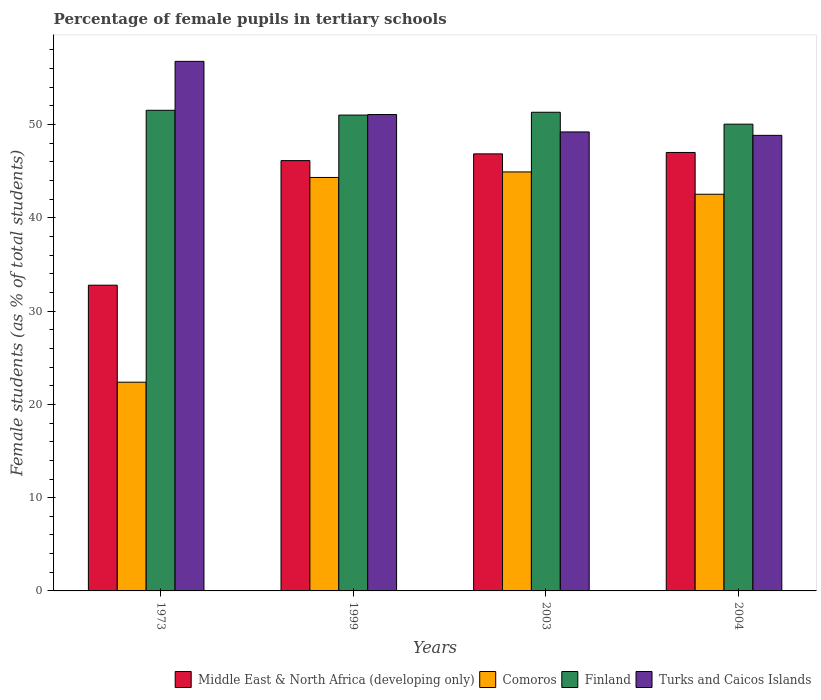How many different coloured bars are there?
Offer a terse response. 4. Are the number of bars on each tick of the X-axis equal?
Your answer should be very brief. Yes. How many bars are there on the 1st tick from the right?
Provide a succinct answer. 4. What is the percentage of female pupils in tertiary schools in Comoros in 1973?
Keep it short and to the point. 22.38. Across all years, what is the maximum percentage of female pupils in tertiary schools in Finland?
Your answer should be compact. 51.53. Across all years, what is the minimum percentage of female pupils in tertiary schools in Turks and Caicos Islands?
Keep it short and to the point. 48.85. In which year was the percentage of female pupils in tertiary schools in Finland maximum?
Ensure brevity in your answer.  1973. In which year was the percentage of female pupils in tertiary schools in Comoros minimum?
Ensure brevity in your answer.  1973. What is the total percentage of female pupils in tertiary schools in Comoros in the graph?
Keep it short and to the point. 154.16. What is the difference between the percentage of female pupils in tertiary schools in Middle East & North Africa (developing only) in 1973 and that in 2003?
Make the answer very short. -14.08. What is the difference between the percentage of female pupils in tertiary schools in Finland in 2003 and the percentage of female pupils in tertiary schools in Turks and Caicos Islands in 1999?
Ensure brevity in your answer.  0.24. What is the average percentage of female pupils in tertiary schools in Turks and Caicos Islands per year?
Offer a very short reply. 51.48. In the year 1973, what is the difference between the percentage of female pupils in tertiary schools in Middle East & North Africa (developing only) and percentage of female pupils in tertiary schools in Turks and Caicos Islands?
Offer a terse response. -24. What is the ratio of the percentage of female pupils in tertiary schools in Middle East & North Africa (developing only) in 1973 to that in 2004?
Provide a short and direct response. 0.7. Is the percentage of female pupils in tertiary schools in Middle East & North Africa (developing only) in 1973 less than that in 2004?
Offer a terse response. Yes. What is the difference between the highest and the second highest percentage of female pupils in tertiary schools in Comoros?
Your response must be concise. 0.59. What is the difference between the highest and the lowest percentage of female pupils in tertiary schools in Finland?
Your answer should be compact. 1.49. Is it the case that in every year, the sum of the percentage of female pupils in tertiary schools in Turks and Caicos Islands and percentage of female pupils in tertiary schools in Middle East & North Africa (developing only) is greater than the sum of percentage of female pupils in tertiary schools in Finland and percentage of female pupils in tertiary schools in Comoros?
Keep it short and to the point. No. What does the 1st bar from the left in 2003 represents?
Give a very brief answer. Middle East & North Africa (developing only). What does the 4th bar from the right in 1973 represents?
Make the answer very short. Middle East & North Africa (developing only). What is the difference between two consecutive major ticks on the Y-axis?
Provide a short and direct response. 10. Where does the legend appear in the graph?
Ensure brevity in your answer.  Bottom right. How many legend labels are there?
Give a very brief answer. 4. How are the legend labels stacked?
Your response must be concise. Horizontal. What is the title of the graph?
Provide a short and direct response. Percentage of female pupils in tertiary schools. What is the label or title of the Y-axis?
Your answer should be very brief. Female students (as % of total students). What is the Female students (as % of total students) of Middle East & North Africa (developing only) in 1973?
Ensure brevity in your answer.  32.78. What is the Female students (as % of total students) in Comoros in 1973?
Keep it short and to the point. 22.38. What is the Female students (as % of total students) of Finland in 1973?
Provide a succinct answer. 51.53. What is the Female students (as % of total students) of Turks and Caicos Islands in 1973?
Ensure brevity in your answer.  56.78. What is the Female students (as % of total students) of Middle East & North Africa (developing only) in 1999?
Keep it short and to the point. 46.14. What is the Female students (as % of total students) of Comoros in 1999?
Offer a terse response. 44.33. What is the Female students (as % of total students) of Finland in 1999?
Provide a succinct answer. 51.02. What is the Female students (as % of total students) in Turks and Caicos Islands in 1999?
Your answer should be very brief. 51.08. What is the Female students (as % of total students) in Middle East & North Africa (developing only) in 2003?
Keep it short and to the point. 46.86. What is the Female students (as % of total students) of Comoros in 2003?
Make the answer very short. 44.92. What is the Female students (as % of total students) in Finland in 2003?
Provide a short and direct response. 51.32. What is the Female students (as % of total students) in Turks and Caicos Islands in 2003?
Provide a short and direct response. 49.21. What is the Female students (as % of total students) of Middle East & North Africa (developing only) in 2004?
Provide a succinct answer. 47.01. What is the Female students (as % of total students) in Comoros in 2004?
Your answer should be very brief. 42.53. What is the Female students (as % of total students) of Finland in 2004?
Ensure brevity in your answer.  50.04. What is the Female students (as % of total students) in Turks and Caicos Islands in 2004?
Offer a very short reply. 48.85. Across all years, what is the maximum Female students (as % of total students) in Middle East & North Africa (developing only)?
Make the answer very short. 47.01. Across all years, what is the maximum Female students (as % of total students) of Comoros?
Ensure brevity in your answer.  44.92. Across all years, what is the maximum Female students (as % of total students) of Finland?
Keep it short and to the point. 51.53. Across all years, what is the maximum Female students (as % of total students) of Turks and Caicos Islands?
Your response must be concise. 56.78. Across all years, what is the minimum Female students (as % of total students) of Middle East & North Africa (developing only)?
Your answer should be very brief. 32.78. Across all years, what is the minimum Female students (as % of total students) in Comoros?
Make the answer very short. 22.38. Across all years, what is the minimum Female students (as % of total students) in Finland?
Keep it short and to the point. 50.04. Across all years, what is the minimum Female students (as % of total students) in Turks and Caicos Islands?
Make the answer very short. 48.85. What is the total Female students (as % of total students) in Middle East & North Africa (developing only) in the graph?
Offer a very short reply. 172.79. What is the total Female students (as % of total students) of Comoros in the graph?
Provide a short and direct response. 154.16. What is the total Female students (as % of total students) in Finland in the graph?
Provide a short and direct response. 203.92. What is the total Female students (as % of total students) of Turks and Caicos Islands in the graph?
Provide a short and direct response. 205.92. What is the difference between the Female students (as % of total students) of Middle East & North Africa (developing only) in 1973 and that in 1999?
Your answer should be very brief. -13.36. What is the difference between the Female students (as % of total students) in Comoros in 1973 and that in 1999?
Make the answer very short. -21.95. What is the difference between the Female students (as % of total students) in Finland in 1973 and that in 1999?
Your answer should be very brief. 0.52. What is the difference between the Female students (as % of total students) of Turks and Caicos Islands in 1973 and that in 1999?
Your response must be concise. 5.7. What is the difference between the Female students (as % of total students) of Middle East & North Africa (developing only) in 1973 and that in 2003?
Your response must be concise. -14.08. What is the difference between the Female students (as % of total students) in Comoros in 1973 and that in 2003?
Ensure brevity in your answer.  -22.54. What is the difference between the Female students (as % of total students) in Finland in 1973 and that in 2003?
Offer a very short reply. 0.21. What is the difference between the Female students (as % of total students) in Turks and Caicos Islands in 1973 and that in 2003?
Your response must be concise. 7.57. What is the difference between the Female students (as % of total students) of Middle East & North Africa (developing only) in 1973 and that in 2004?
Your answer should be very brief. -14.23. What is the difference between the Female students (as % of total students) in Comoros in 1973 and that in 2004?
Provide a succinct answer. -20.15. What is the difference between the Female students (as % of total students) in Finland in 1973 and that in 2004?
Your answer should be compact. 1.49. What is the difference between the Female students (as % of total students) of Turks and Caicos Islands in 1973 and that in 2004?
Provide a succinct answer. 7.93. What is the difference between the Female students (as % of total students) in Middle East & North Africa (developing only) in 1999 and that in 2003?
Offer a very short reply. -0.72. What is the difference between the Female students (as % of total students) in Comoros in 1999 and that in 2003?
Provide a succinct answer. -0.59. What is the difference between the Female students (as % of total students) in Finland in 1999 and that in 2003?
Offer a very short reply. -0.3. What is the difference between the Female students (as % of total students) of Turks and Caicos Islands in 1999 and that in 2003?
Your response must be concise. 1.86. What is the difference between the Female students (as % of total students) in Middle East & North Africa (developing only) in 1999 and that in 2004?
Offer a very short reply. -0.87. What is the difference between the Female students (as % of total students) of Comoros in 1999 and that in 2004?
Provide a short and direct response. 1.8. What is the difference between the Female students (as % of total students) of Finland in 1999 and that in 2004?
Make the answer very short. 0.97. What is the difference between the Female students (as % of total students) in Turks and Caicos Islands in 1999 and that in 2004?
Your answer should be compact. 2.23. What is the difference between the Female students (as % of total students) of Middle East & North Africa (developing only) in 2003 and that in 2004?
Keep it short and to the point. -0.15. What is the difference between the Female students (as % of total students) of Comoros in 2003 and that in 2004?
Provide a succinct answer. 2.39. What is the difference between the Female students (as % of total students) in Finland in 2003 and that in 2004?
Provide a short and direct response. 1.28. What is the difference between the Female students (as % of total students) of Turks and Caicos Islands in 2003 and that in 2004?
Provide a short and direct response. 0.37. What is the difference between the Female students (as % of total students) in Middle East & North Africa (developing only) in 1973 and the Female students (as % of total students) in Comoros in 1999?
Keep it short and to the point. -11.55. What is the difference between the Female students (as % of total students) of Middle East & North Africa (developing only) in 1973 and the Female students (as % of total students) of Finland in 1999?
Make the answer very short. -18.24. What is the difference between the Female students (as % of total students) of Middle East & North Africa (developing only) in 1973 and the Female students (as % of total students) of Turks and Caicos Islands in 1999?
Ensure brevity in your answer.  -18.3. What is the difference between the Female students (as % of total students) in Comoros in 1973 and the Female students (as % of total students) in Finland in 1999?
Your answer should be very brief. -28.64. What is the difference between the Female students (as % of total students) of Comoros in 1973 and the Female students (as % of total students) of Turks and Caicos Islands in 1999?
Your response must be concise. -28.7. What is the difference between the Female students (as % of total students) of Finland in 1973 and the Female students (as % of total students) of Turks and Caicos Islands in 1999?
Offer a terse response. 0.46. What is the difference between the Female students (as % of total students) in Middle East & North Africa (developing only) in 1973 and the Female students (as % of total students) in Comoros in 2003?
Offer a terse response. -12.14. What is the difference between the Female students (as % of total students) of Middle East & North Africa (developing only) in 1973 and the Female students (as % of total students) of Finland in 2003?
Your answer should be very brief. -18.54. What is the difference between the Female students (as % of total students) of Middle East & North Africa (developing only) in 1973 and the Female students (as % of total students) of Turks and Caicos Islands in 2003?
Ensure brevity in your answer.  -16.43. What is the difference between the Female students (as % of total students) of Comoros in 1973 and the Female students (as % of total students) of Finland in 2003?
Your answer should be very brief. -28.94. What is the difference between the Female students (as % of total students) in Comoros in 1973 and the Female students (as % of total students) in Turks and Caicos Islands in 2003?
Offer a terse response. -26.83. What is the difference between the Female students (as % of total students) of Finland in 1973 and the Female students (as % of total students) of Turks and Caicos Islands in 2003?
Keep it short and to the point. 2.32. What is the difference between the Female students (as % of total students) in Middle East & North Africa (developing only) in 1973 and the Female students (as % of total students) in Comoros in 2004?
Offer a terse response. -9.75. What is the difference between the Female students (as % of total students) in Middle East & North Africa (developing only) in 1973 and the Female students (as % of total students) in Finland in 2004?
Provide a short and direct response. -17.26. What is the difference between the Female students (as % of total students) in Middle East & North Africa (developing only) in 1973 and the Female students (as % of total students) in Turks and Caicos Islands in 2004?
Your answer should be very brief. -16.07. What is the difference between the Female students (as % of total students) in Comoros in 1973 and the Female students (as % of total students) in Finland in 2004?
Offer a very short reply. -27.67. What is the difference between the Female students (as % of total students) of Comoros in 1973 and the Female students (as % of total students) of Turks and Caicos Islands in 2004?
Offer a very short reply. -26.47. What is the difference between the Female students (as % of total students) of Finland in 1973 and the Female students (as % of total students) of Turks and Caicos Islands in 2004?
Keep it short and to the point. 2.69. What is the difference between the Female students (as % of total students) of Middle East & North Africa (developing only) in 1999 and the Female students (as % of total students) of Comoros in 2003?
Your response must be concise. 1.22. What is the difference between the Female students (as % of total students) in Middle East & North Africa (developing only) in 1999 and the Female students (as % of total students) in Finland in 2003?
Make the answer very short. -5.18. What is the difference between the Female students (as % of total students) of Middle East & North Africa (developing only) in 1999 and the Female students (as % of total students) of Turks and Caicos Islands in 2003?
Keep it short and to the point. -3.07. What is the difference between the Female students (as % of total students) of Comoros in 1999 and the Female students (as % of total students) of Finland in 2003?
Offer a terse response. -6.99. What is the difference between the Female students (as % of total students) in Comoros in 1999 and the Female students (as % of total students) in Turks and Caicos Islands in 2003?
Your response must be concise. -4.88. What is the difference between the Female students (as % of total students) in Finland in 1999 and the Female students (as % of total students) in Turks and Caicos Islands in 2003?
Your answer should be compact. 1.81. What is the difference between the Female students (as % of total students) in Middle East & North Africa (developing only) in 1999 and the Female students (as % of total students) in Comoros in 2004?
Offer a terse response. 3.61. What is the difference between the Female students (as % of total students) in Middle East & North Africa (developing only) in 1999 and the Female students (as % of total students) in Finland in 2004?
Keep it short and to the point. -3.91. What is the difference between the Female students (as % of total students) in Middle East & North Africa (developing only) in 1999 and the Female students (as % of total students) in Turks and Caicos Islands in 2004?
Your answer should be compact. -2.71. What is the difference between the Female students (as % of total students) of Comoros in 1999 and the Female students (as % of total students) of Finland in 2004?
Your response must be concise. -5.71. What is the difference between the Female students (as % of total students) of Comoros in 1999 and the Female students (as % of total students) of Turks and Caicos Islands in 2004?
Make the answer very short. -4.51. What is the difference between the Female students (as % of total students) in Finland in 1999 and the Female students (as % of total students) in Turks and Caicos Islands in 2004?
Provide a succinct answer. 2.17. What is the difference between the Female students (as % of total students) in Middle East & North Africa (developing only) in 2003 and the Female students (as % of total students) in Comoros in 2004?
Provide a short and direct response. 4.33. What is the difference between the Female students (as % of total students) of Middle East & North Africa (developing only) in 2003 and the Female students (as % of total students) of Finland in 2004?
Provide a succinct answer. -3.18. What is the difference between the Female students (as % of total students) in Middle East & North Africa (developing only) in 2003 and the Female students (as % of total students) in Turks and Caicos Islands in 2004?
Offer a very short reply. -1.98. What is the difference between the Female students (as % of total students) of Comoros in 2003 and the Female students (as % of total students) of Finland in 2004?
Provide a succinct answer. -5.12. What is the difference between the Female students (as % of total students) in Comoros in 2003 and the Female students (as % of total students) in Turks and Caicos Islands in 2004?
Your response must be concise. -3.92. What is the difference between the Female students (as % of total students) of Finland in 2003 and the Female students (as % of total students) of Turks and Caicos Islands in 2004?
Your answer should be very brief. 2.48. What is the average Female students (as % of total students) in Middle East & North Africa (developing only) per year?
Provide a short and direct response. 43.2. What is the average Female students (as % of total students) of Comoros per year?
Your answer should be very brief. 38.54. What is the average Female students (as % of total students) in Finland per year?
Provide a short and direct response. 50.98. What is the average Female students (as % of total students) in Turks and Caicos Islands per year?
Your response must be concise. 51.48. In the year 1973, what is the difference between the Female students (as % of total students) in Middle East & North Africa (developing only) and Female students (as % of total students) in Comoros?
Ensure brevity in your answer.  10.4. In the year 1973, what is the difference between the Female students (as % of total students) of Middle East & North Africa (developing only) and Female students (as % of total students) of Finland?
Offer a very short reply. -18.75. In the year 1973, what is the difference between the Female students (as % of total students) of Middle East & North Africa (developing only) and Female students (as % of total students) of Turks and Caicos Islands?
Offer a very short reply. -24. In the year 1973, what is the difference between the Female students (as % of total students) of Comoros and Female students (as % of total students) of Finland?
Provide a succinct answer. -29.15. In the year 1973, what is the difference between the Female students (as % of total students) in Comoros and Female students (as % of total students) in Turks and Caicos Islands?
Keep it short and to the point. -34.4. In the year 1973, what is the difference between the Female students (as % of total students) of Finland and Female students (as % of total students) of Turks and Caicos Islands?
Give a very brief answer. -5.25. In the year 1999, what is the difference between the Female students (as % of total students) of Middle East & North Africa (developing only) and Female students (as % of total students) of Comoros?
Your answer should be very brief. 1.81. In the year 1999, what is the difference between the Female students (as % of total students) in Middle East & North Africa (developing only) and Female students (as % of total students) in Finland?
Make the answer very short. -4.88. In the year 1999, what is the difference between the Female students (as % of total students) of Middle East & North Africa (developing only) and Female students (as % of total students) of Turks and Caicos Islands?
Provide a succinct answer. -4.94. In the year 1999, what is the difference between the Female students (as % of total students) of Comoros and Female students (as % of total students) of Finland?
Give a very brief answer. -6.69. In the year 1999, what is the difference between the Female students (as % of total students) in Comoros and Female students (as % of total students) in Turks and Caicos Islands?
Provide a succinct answer. -6.75. In the year 1999, what is the difference between the Female students (as % of total students) of Finland and Female students (as % of total students) of Turks and Caicos Islands?
Your answer should be compact. -0.06. In the year 2003, what is the difference between the Female students (as % of total students) of Middle East & North Africa (developing only) and Female students (as % of total students) of Comoros?
Offer a very short reply. 1.94. In the year 2003, what is the difference between the Female students (as % of total students) in Middle East & North Africa (developing only) and Female students (as % of total students) in Finland?
Make the answer very short. -4.46. In the year 2003, what is the difference between the Female students (as % of total students) of Middle East & North Africa (developing only) and Female students (as % of total students) of Turks and Caicos Islands?
Your response must be concise. -2.35. In the year 2003, what is the difference between the Female students (as % of total students) of Comoros and Female students (as % of total students) of Finland?
Provide a succinct answer. -6.4. In the year 2003, what is the difference between the Female students (as % of total students) in Comoros and Female students (as % of total students) in Turks and Caicos Islands?
Provide a short and direct response. -4.29. In the year 2003, what is the difference between the Female students (as % of total students) of Finland and Female students (as % of total students) of Turks and Caicos Islands?
Your answer should be very brief. 2.11. In the year 2004, what is the difference between the Female students (as % of total students) in Middle East & North Africa (developing only) and Female students (as % of total students) in Comoros?
Ensure brevity in your answer.  4.48. In the year 2004, what is the difference between the Female students (as % of total students) of Middle East & North Africa (developing only) and Female students (as % of total students) of Finland?
Provide a short and direct response. -3.03. In the year 2004, what is the difference between the Female students (as % of total students) of Middle East & North Africa (developing only) and Female students (as % of total students) of Turks and Caicos Islands?
Make the answer very short. -1.83. In the year 2004, what is the difference between the Female students (as % of total students) in Comoros and Female students (as % of total students) in Finland?
Provide a succinct answer. -7.51. In the year 2004, what is the difference between the Female students (as % of total students) in Comoros and Female students (as % of total students) in Turks and Caicos Islands?
Your answer should be very brief. -6.31. In the year 2004, what is the difference between the Female students (as % of total students) of Finland and Female students (as % of total students) of Turks and Caicos Islands?
Offer a terse response. 1.2. What is the ratio of the Female students (as % of total students) of Middle East & North Africa (developing only) in 1973 to that in 1999?
Your response must be concise. 0.71. What is the ratio of the Female students (as % of total students) in Comoros in 1973 to that in 1999?
Your response must be concise. 0.5. What is the ratio of the Female students (as % of total students) in Turks and Caicos Islands in 1973 to that in 1999?
Your answer should be very brief. 1.11. What is the ratio of the Female students (as % of total students) in Middle East & North Africa (developing only) in 1973 to that in 2003?
Give a very brief answer. 0.7. What is the ratio of the Female students (as % of total students) in Comoros in 1973 to that in 2003?
Offer a terse response. 0.5. What is the ratio of the Female students (as % of total students) of Turks and Caicos Islands in 1973 to that in 2003?
Your answer should be very brief. 1.15. What is the ratio of the Female students (as % of total students) in Middle East & North Africa (developing only) in 1973 to that in 2004?
Give a very brief answer. 0.7. What is the ratio of the Female students (as % of total students) of Comoros in 1973 to that in 2004?
Provide a short and direct response. 0.53. What is the ratio of the Female students (as % of total students) in Finland in 1973 to that in 2004?
Give a very brief answer. 1.03. What is the ratio of the Female students (as % of total students) of Turks and Caicos Islands in 1973 to that in 2004?
Make the answer very short. 1.16. What is the ratio of the Female students (as % of total students) in Middle East & North Africa (developing only) in 1999 to that in 2003?
Provide a short and direct response. 0.98. What is the ratio of the Female students (as % of total students) of Comoros in 1999 to that in 2003?
Your answer should be compact. 0.99. What is the ratio of the Female students (as % of total students) in Finland in 1999 to that in 2003?
Offer a very short reply. 0.99. What is the ratio of the Female students (as % of total students) in Turks and Caicos Islands in 1999 to that in 2003?
Provide a succinct answer. 1.04. What is the ratio of the Female students (as % of total students) in Middle East & North Africa (developing only) in 1999 to that in 2004?
Your answer should be compact. 0.98. What is the ratio of the Female students (as % of total students) of Comoros in 1999 to that in 2004?
Your answer should be very brief. 1.04. What is the ratio of the Female students (as % of total students) of Finland in 1999 to that in 2004?
Ensure brevity in your answer.  1.02. What is the ratio of the Female students (as % of total students) of Turks and Caicos Islands in 1999 to that in 2004?
Offer a very short reply. 1.05. What is the ratio of the Female students (as % of total students) of Middle East & North Africa (developing only) in 2003 to that in 2004?
Your answer should be compact. 1. What is the ratio of the Female students (as % of total students) of Comoros in 2003 to that in 2004?
Keep it short and to the point. 1.06. What is the ratio of the Female students (as % of total students) of Finland in 2003 to that in 2004?
Ensure brevity in your answer.  1.03. What is the ratio of the Female students (as % of total students) of Turks and Caicos Islands in 2003 to that in 2004?
Your answer should be compact. 1.01. What is the difference between the highest and the second highest Female students (as % of total students) in Middle East & North Africa (developing only)?
Provide a short and direct response. 0.15. What is the difference between the highest and the second highest Female students (as % of total students) of Comoros?
Keep it short and to the point. 0.59. What is the difference between the highest and the second highest Female students (as % of total students) of Finland?
Your answer should be very brief. 0.21. What is the difference between the highest and the second highest Female students (as % of total students) of Turks and Caicos Islands?
Offer a very short reply. 5.7. What is the difference between the highest and the lowest Female students (as % of total students) in Middle East & North Africa (developing only)?
Keep it short and to the point. 14.23. What is the difference between the highest and the lowest Female students (as % of total students) of Comoros?
Your response must be concise. 22.54. What is the difference between the highest and the lowest Female students (as % of total students) of Finland?
Your answer should be very brief. 1.49. What is the difference between the highest and the lowest Female students (as % of total students) of Turks and Caicos Islands?
Your answer should be compact. 7.93. 